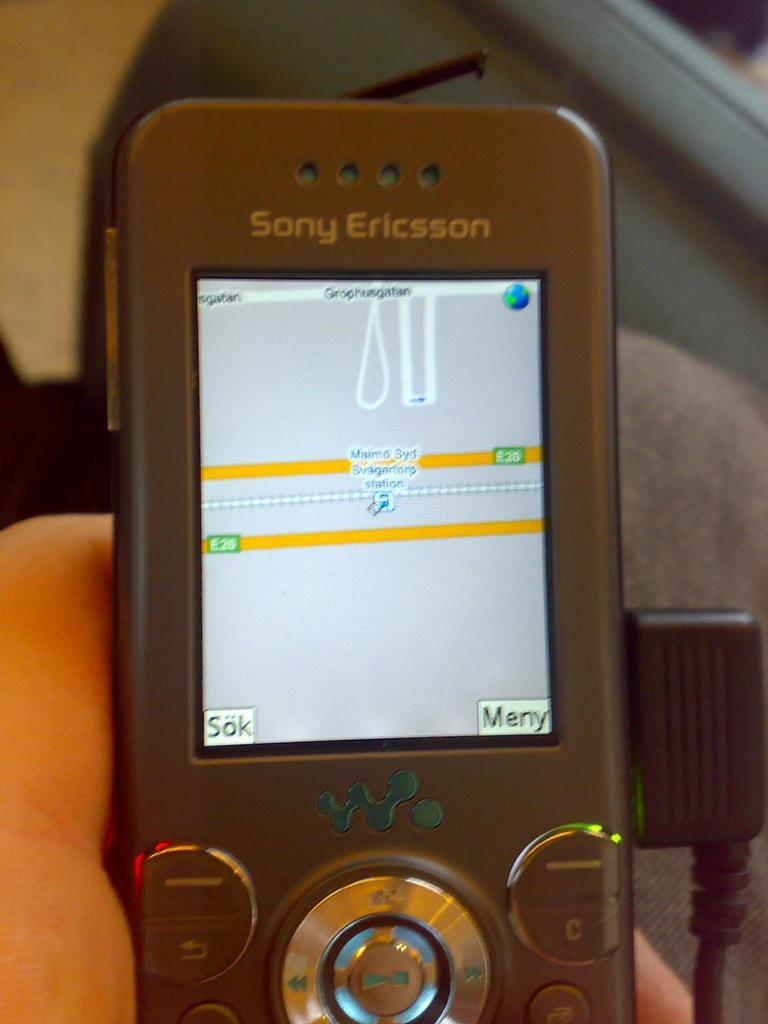<image>
Write a terse but informative summary of the picture. A Sony Ericsson phone shows a map for Maimo Syd. 